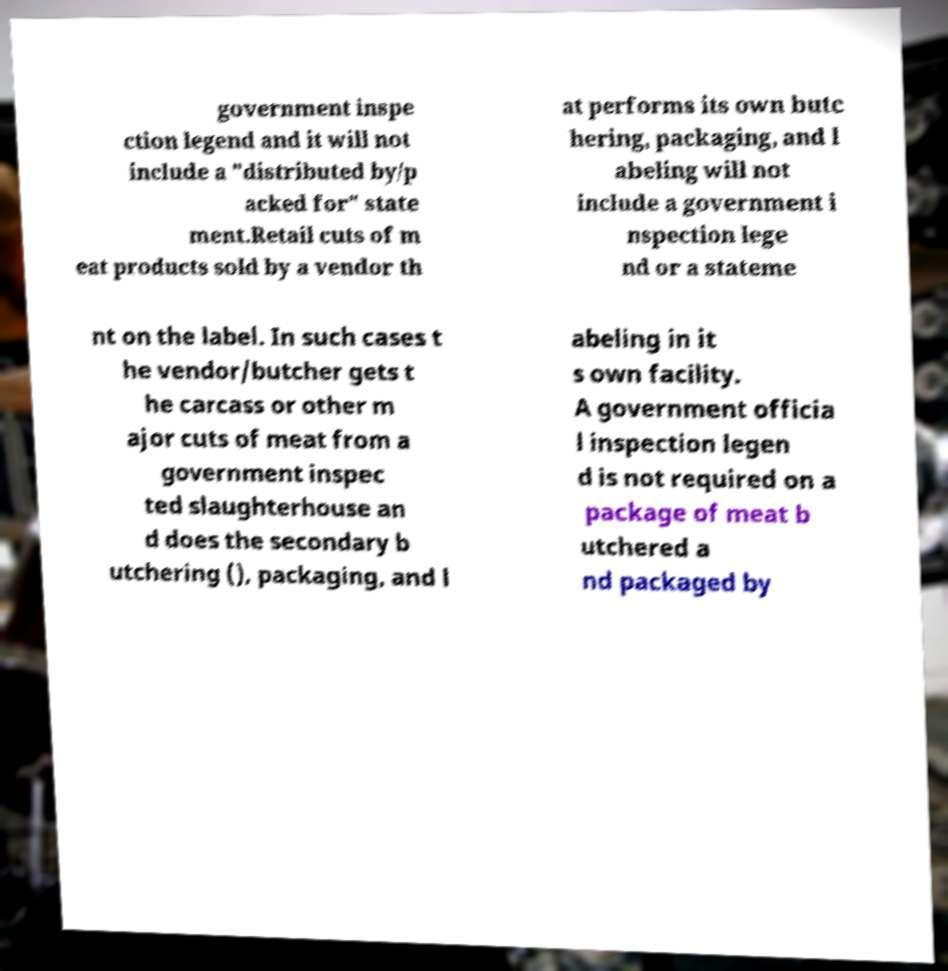What messages or text are displayed in this image? I need them in a readable, typed format. government inspe ction legend and it will not include a "distributed by/p acked for" state ment.Retail cuts of m eat products sold by a vendor th at performs its own butc hering, packaging, and l abeling will not include a government i nspection lege nd or a stateme nt on the label. In such cases t he vendor/butcher gets t he carcass or other m ajor cuts of meat from a government inspec ted slaughterhouse an d does the secondary b utchering (), packaging, and l abeling in it s own facility. A government officia l inspection legen d is not required on a package of meat b utchered a nd packaged by 